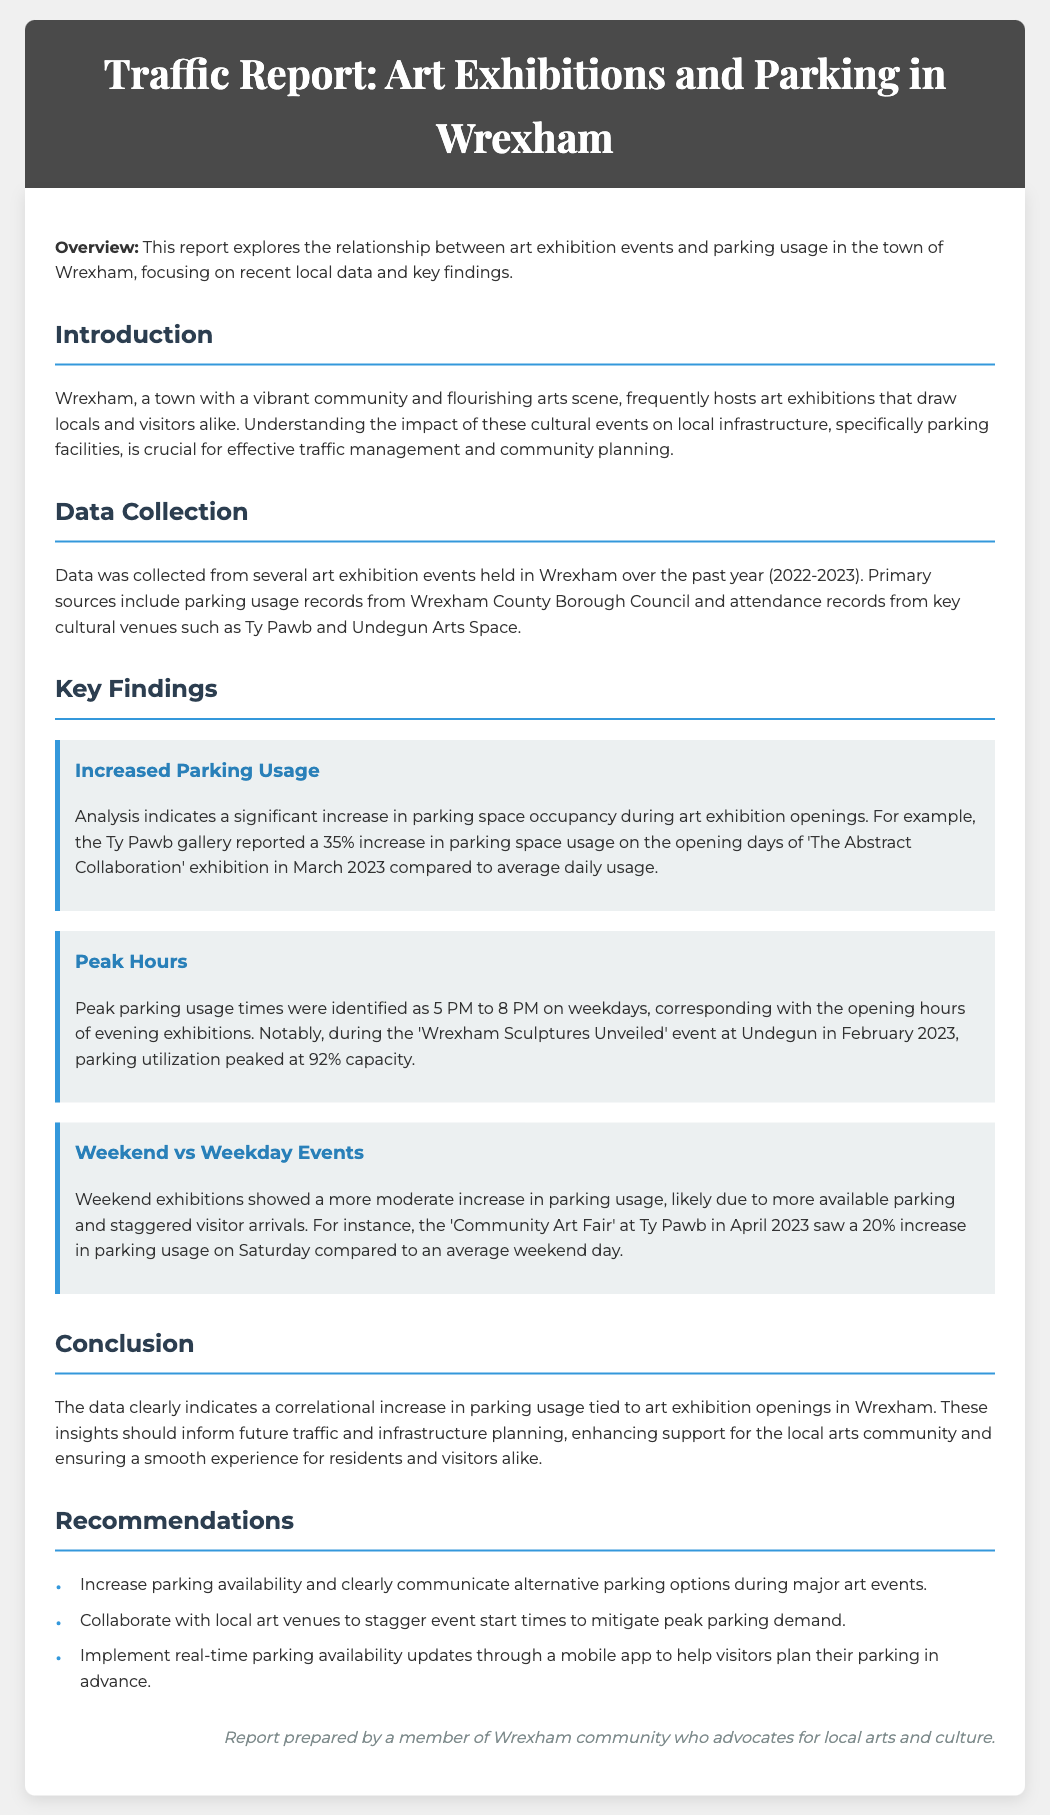What was the increase in parking usage during 'The Abstract Collaboration' exhibition? The report states there was a 35% increase in parking usage.
Answer: 35% What were the peak parking usage hours on weekdays? The identified peak hours for parking usage were from 5 PM to 8 PM.
Answer: 5 PM to 8 PM What was the capacity of parking utilization during the 'Wrexham Sculptures Unveiled' event? It peaked at 92% capacity during this event.
Answer: 92% What type of event showed a more moderate increase in parking usage? Weekend exhibitions showed a more moderate increase in parking usage.
Answer: Weekend exhibitions What percentage increase in parking usage was noted for the 'Community Art Fair' on Saturday? A 20% increase in parking usage was noted for this event.
Answer: 20% What is the main subject of the report? The main subject of the report is the correlation between art exhibition openings and parking usage in Wrexham.
Answer: Correlation between art exhibition openings and parking usage What recommendations are made for handling parking during major art events? The recommendations include increasing parking availability and communicating alternative options.
Answer: Increase parking availability Who prepared this report? The report was prepared by a member of Wrexham community who advocates for local arts and culture.
Answer: A member of Wrexham community 